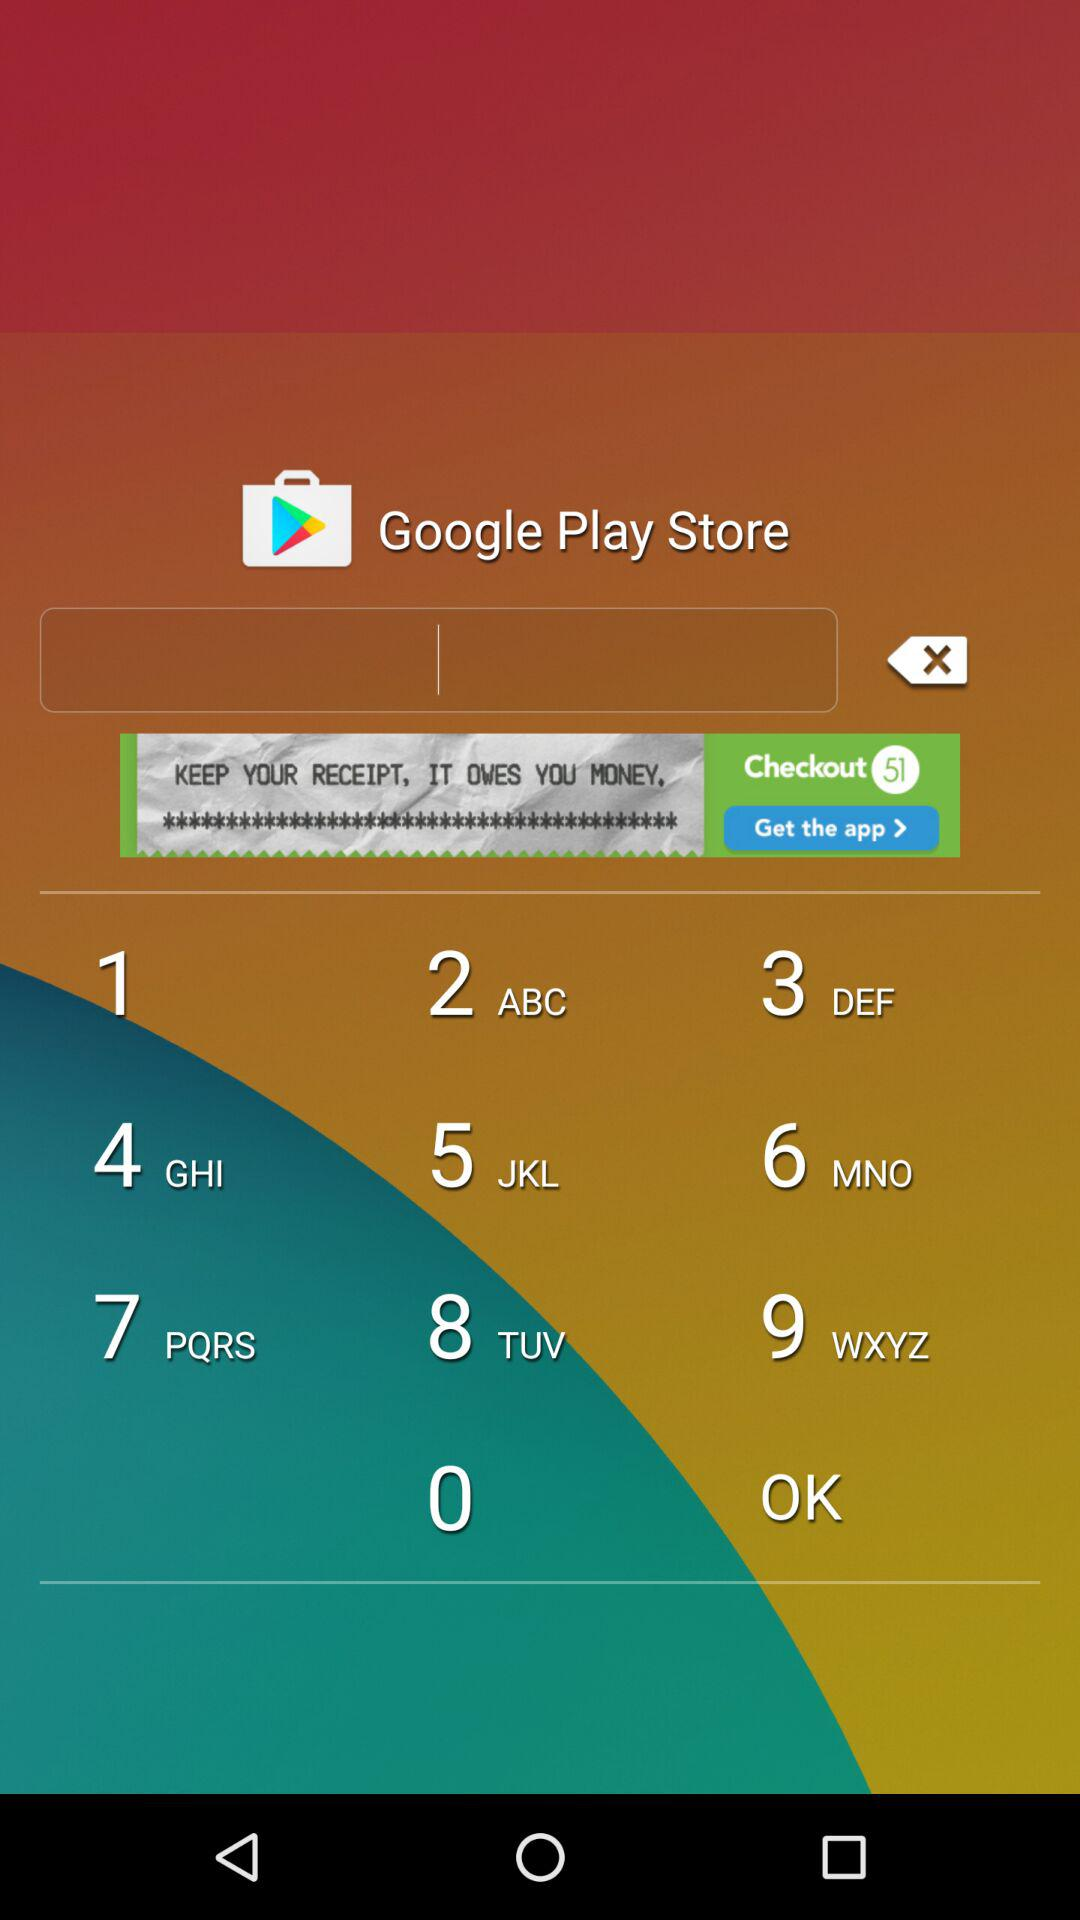What is the user name?
When the provided information is insufficient, respond with <no answer>. <no answer> 